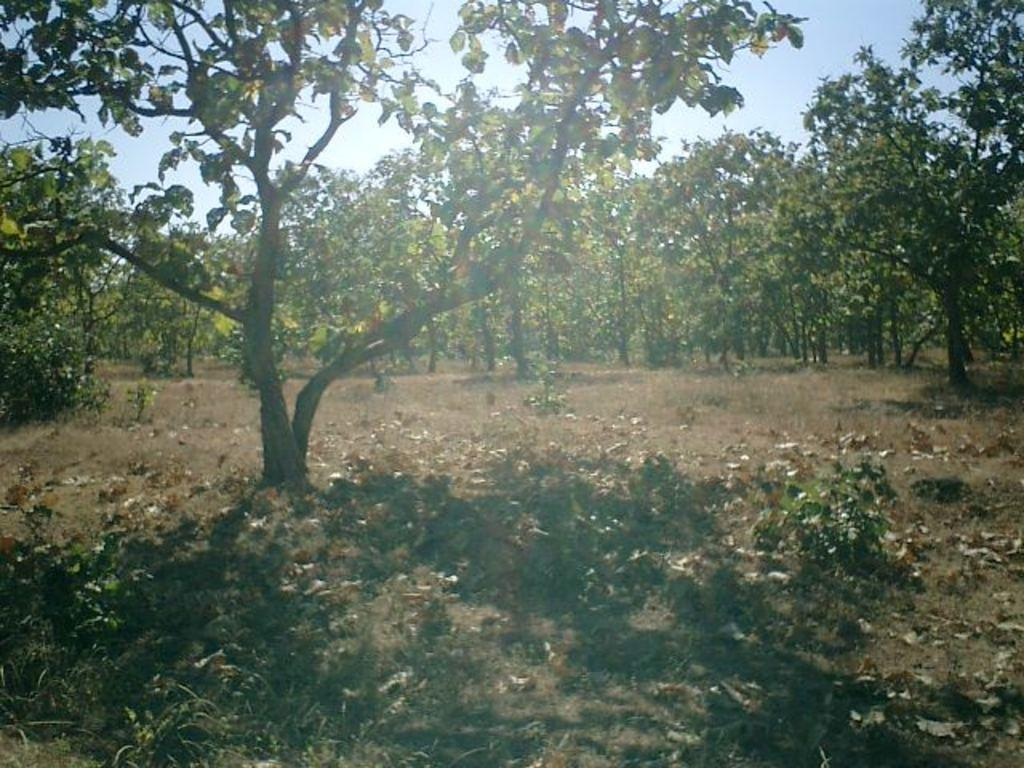What type of vegetation can be seen in the image? There are trees in the image. What part of the natural environment is visible in the image? The sky is visible in the background of the image. What is the monetary value of the trees in the image? There is no information about the monetary value of the trees in the image, as the facts provided only mention their presence and type. 